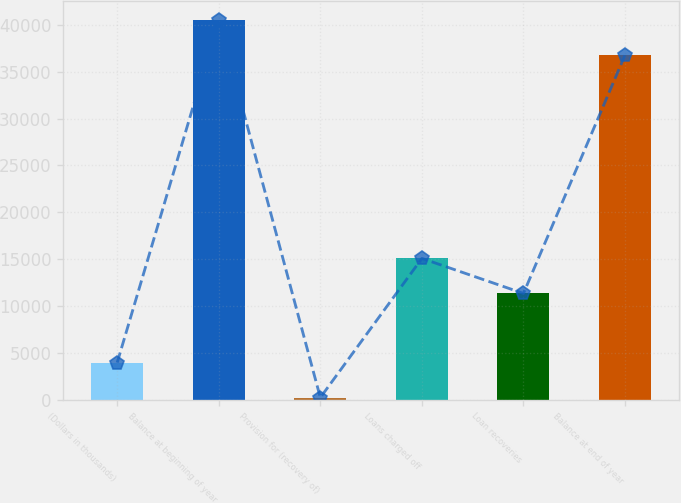Convert chart. <chart><loc_0><loc_0><loc_500><loc_500><bar_chart><fcel>(Dollars in thousands)<fcel>Balance at beginning of year<fcel>Provision for (recovery of)<fcel>Loans charged off<fcel>Loan recoveries<fcel>Balance at end of year<nl><fcel>3974.6<fcel>40522.6<fcel>237<fcel>15088.6<fcel>11351<fcel>36785<nl></chart> 